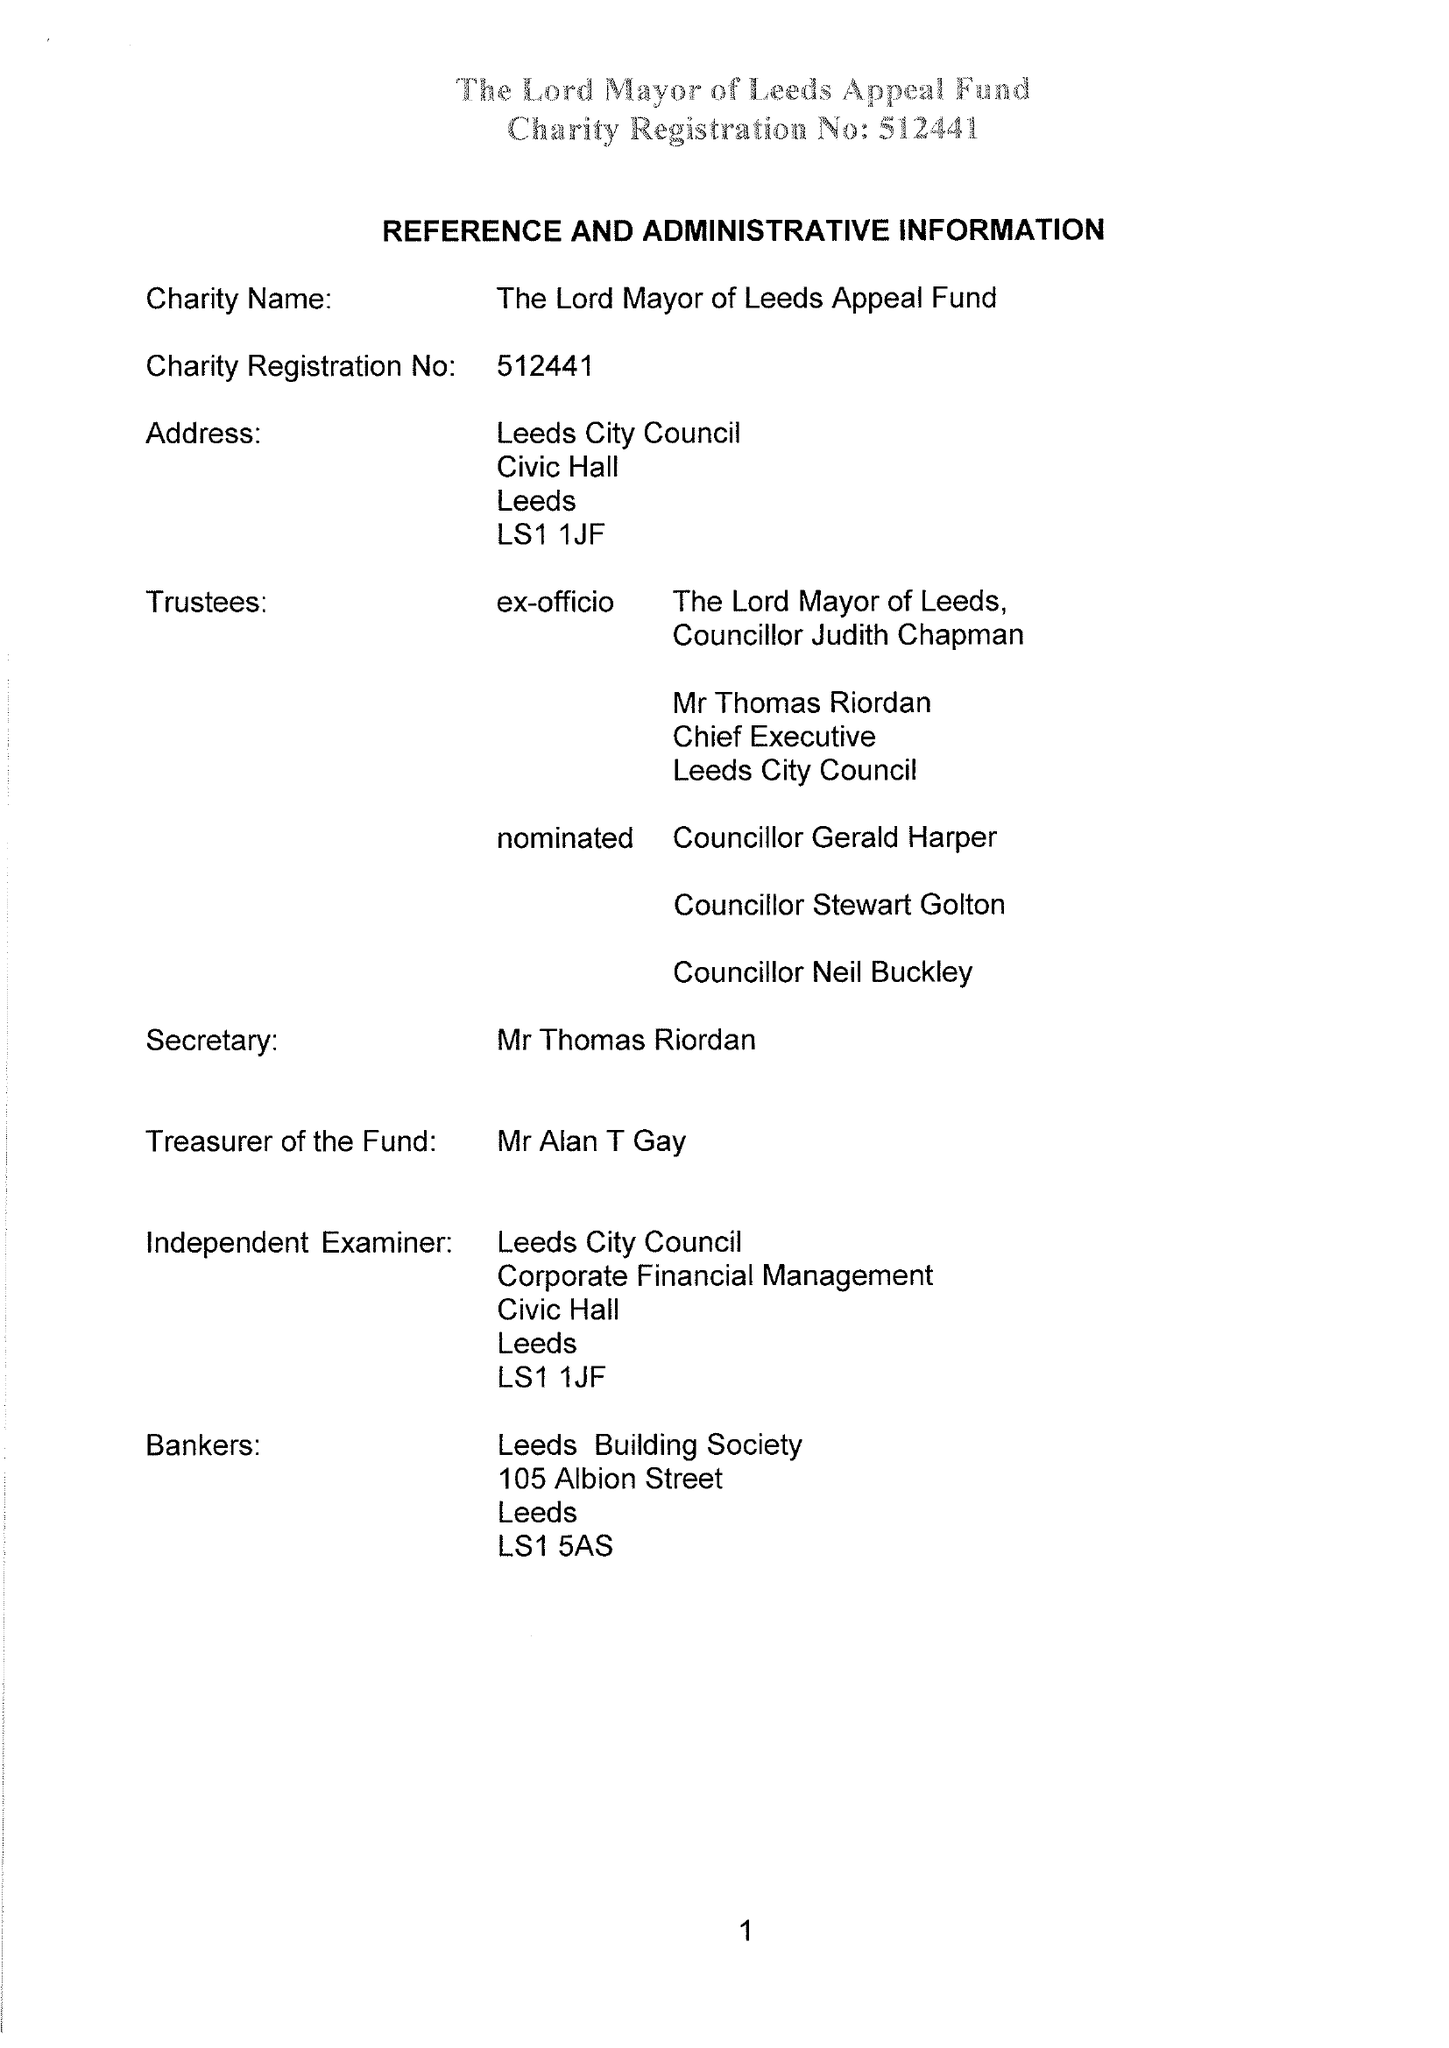What is the value for the income_annually_in_british_pounds?
Answer the question using a single word or phrase. 52262.00 